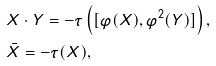<formula> <loc_0><loc_0><loc_500><loc_500>& X \cdot Y = - \tau \left ( [ \varphi ( X ) , \varphi ^ { 2 } ( Y ) ] \right ) , \\ & \bar { X } = - \tau ( X ) ,</formula> 